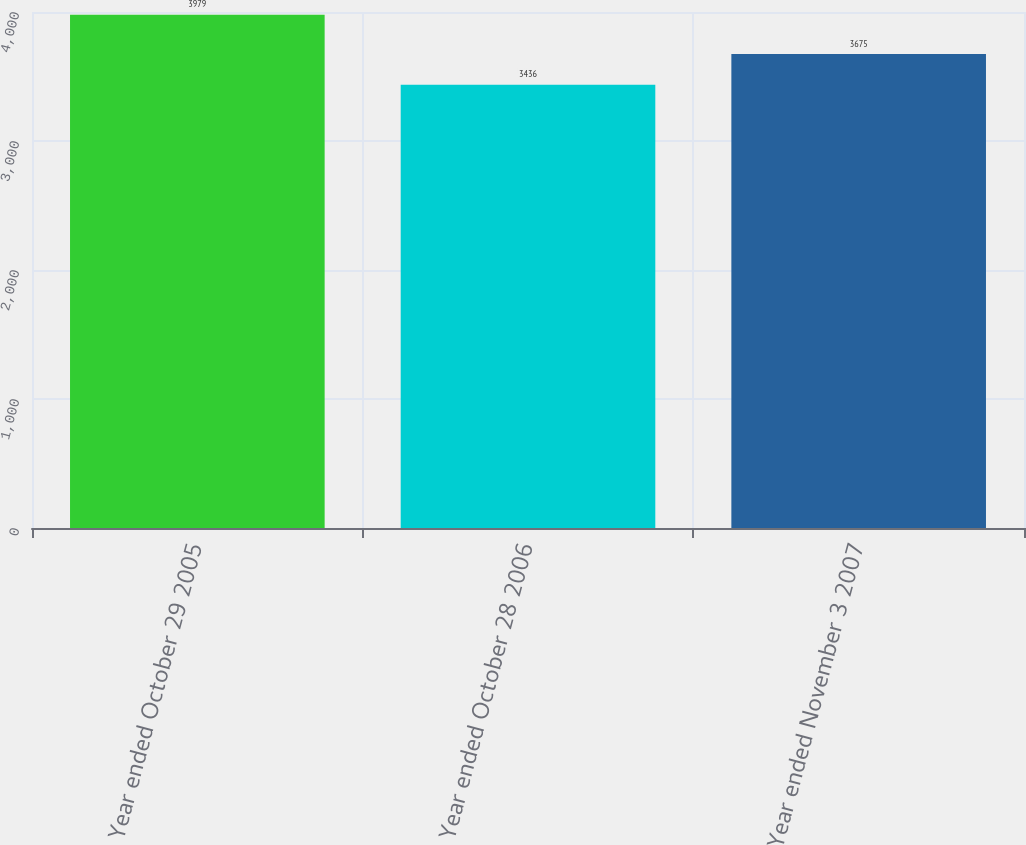<chart> <loc_0><loc_0><loc_500><loc_500><bar_chart><fcel>Year ended October 29 2005<fcel>Year ended October 28 2006<fcel>Year ended November 3 2007<nl><fcel>3979<fcel>3436<fcel>3675<nl></chart> 